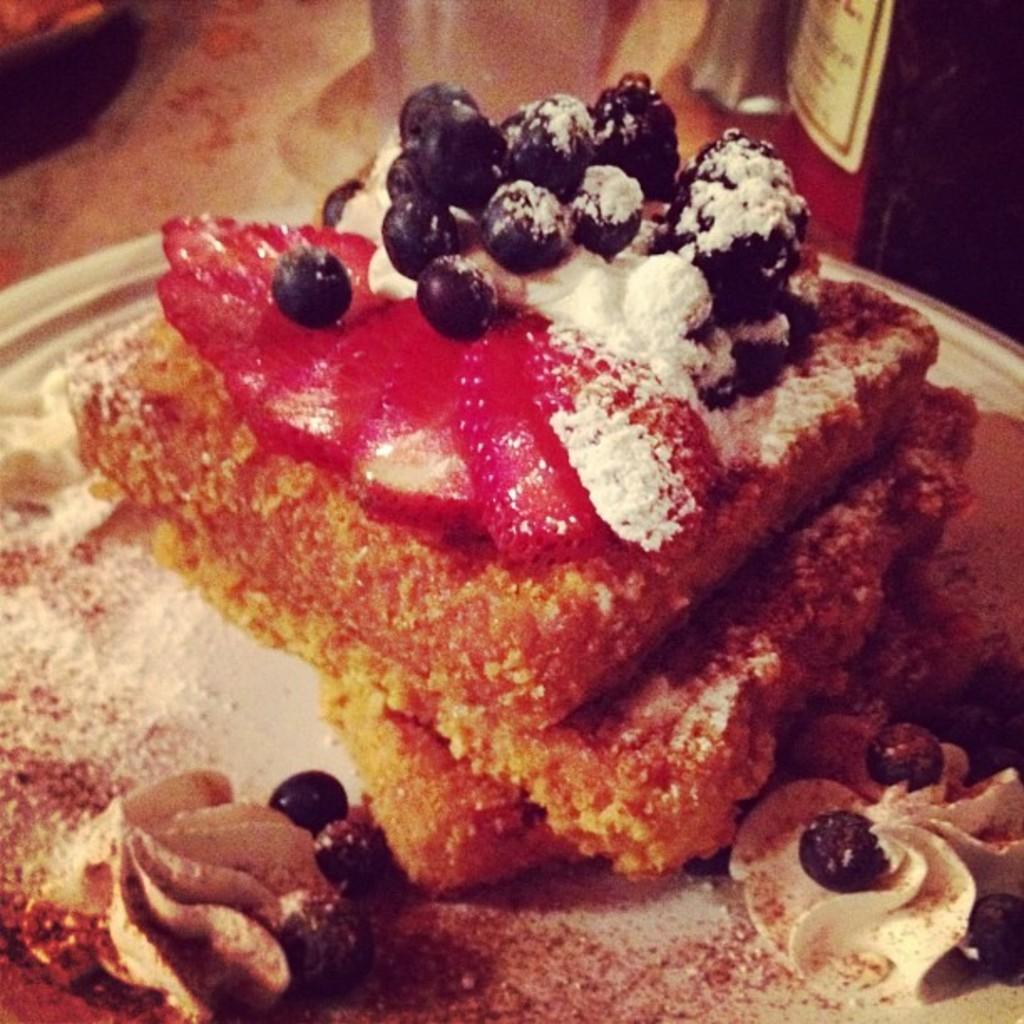Could you give a brief overview of what you see in this image? In this image there is a food item on the plate. 